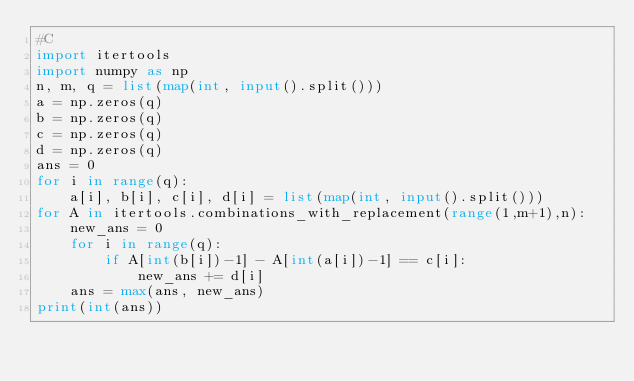Convert code to text. <code><loc_0><loc_0><loc_500><loc_500><_Python_>#C
import itertools
import numpy as np
n, m, q = list(map(int, input().split()))
a = np.zeros(q)
b = np.zeros(q)
c = np.zeros(q)
d = np.zeros(q)
ans = 0
for i in range(q):
    a[i], b[i], c[i], d[i] = list(map(int, input().split()))
for A in itertools.combinations_with_replacement(range(1,m+1),n):
    new_ans = 0
    for i in range(q):
        if A[int(b[i])-1] - A[int(a[i])-1] == c[i]:
            new_ans += d[i]
    ans = max(ans, new_ans)
print(int(ans))</code> 